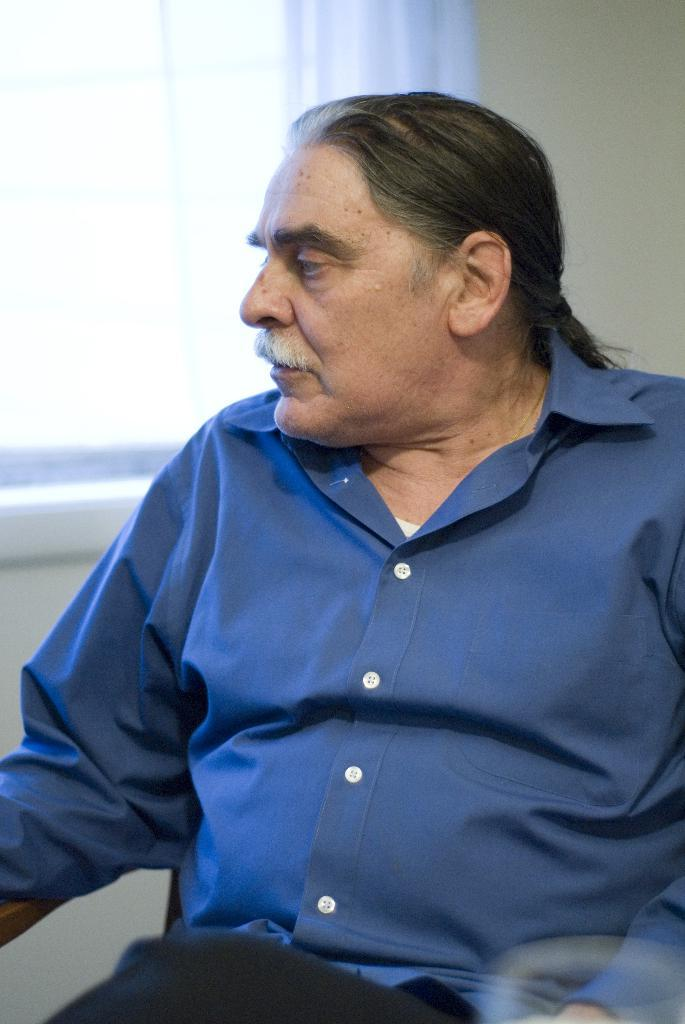Who or what is present in the image? There is a person in the image. What is the person wearing? The person is wearing clothes. What architectural feature can be seen in the image? There is a window in the top left of the image. What type of thread is being used by the person in the image? There is no thread present in the image, and the person is not shown using any thread. 